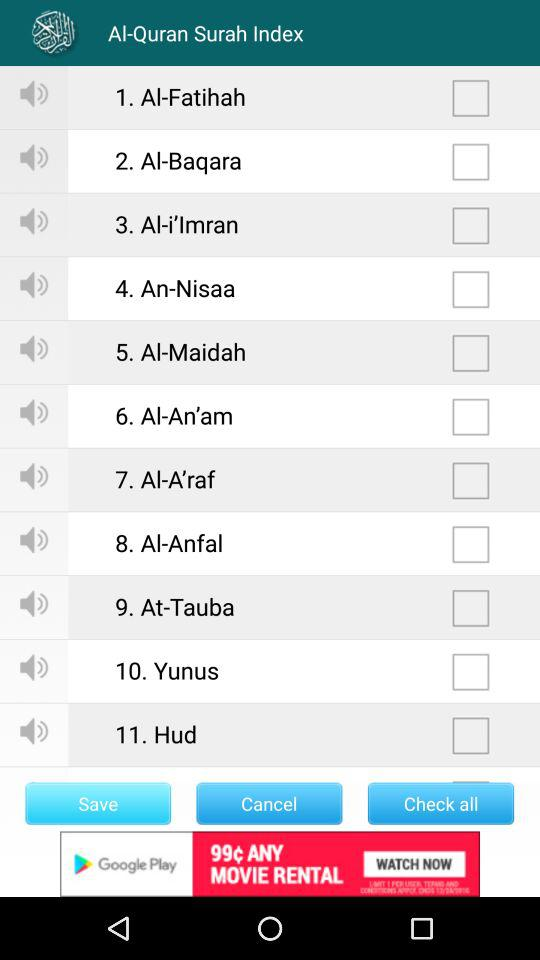How many items are checked?
Answer the question using a single word or phrase. 0 